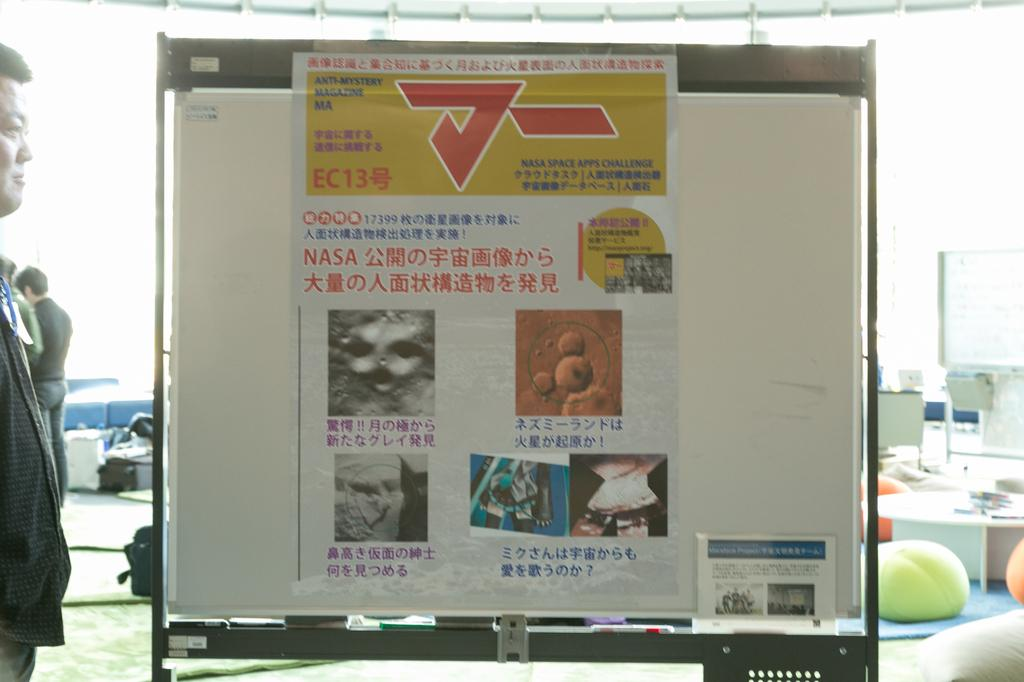<image>
Describe the image concisely. A picture on a sign from anti-mystery magazine. 